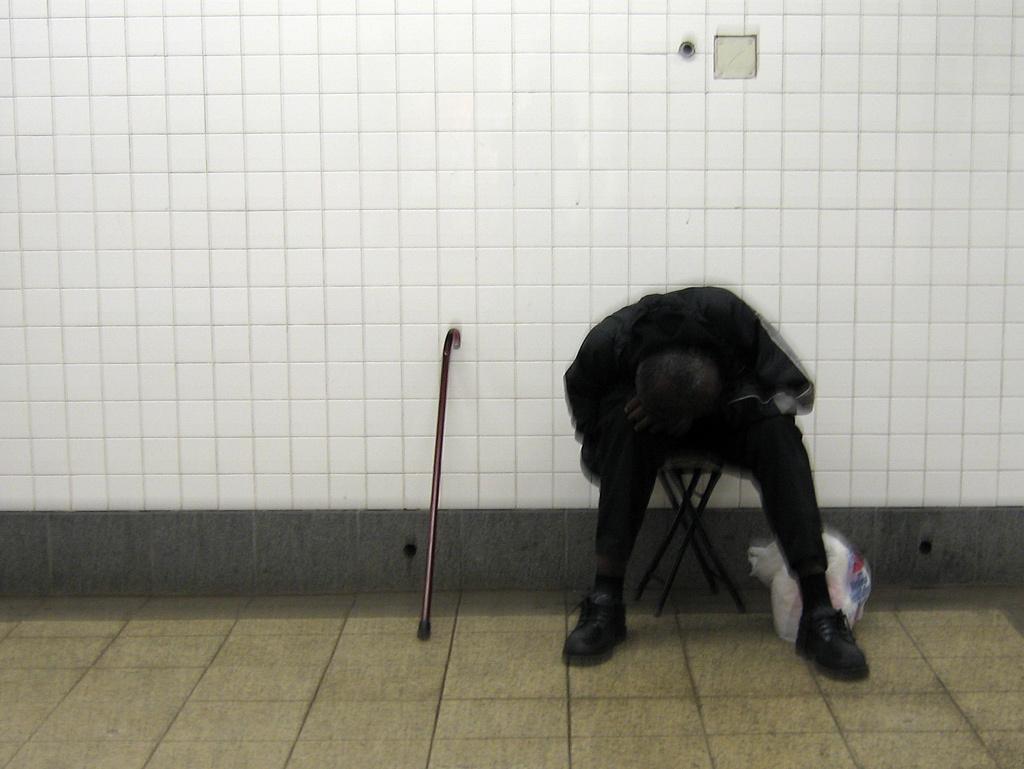In one or two sentences, can you explain what this image depicts? There is a person sitting on a chair. Near to him there is a walking stick and a packet. In the back there is a wall. 